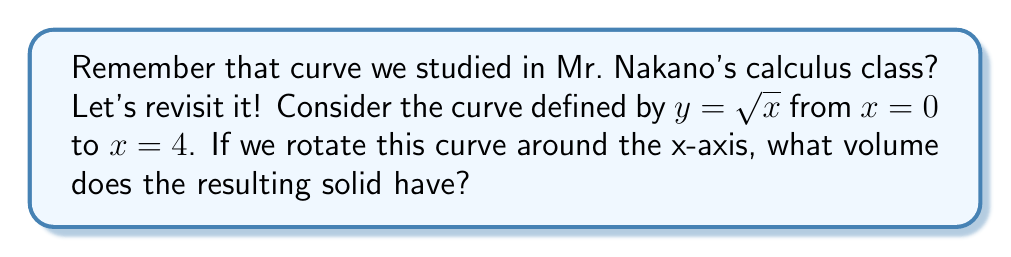What is the answer to this math problem? Let's approach this step-by-step:

1) To find the volume of a solid formed by rotating a curve around the x-axis, we use the disk method. The formula is:

   $$V = \pi \int_a^b [f(x)]^2 dx$$

   where $f(x)$ is our function and $[a,b]$ is our interval.

2) In this case, $f(x) = \sqrt{x}$, $a = 0$, and $b = 4$.

3) Let's substitute these into our formula:

   $$V = \pi \int_0^4 (\sqrt{x})^2 dx$$

4) Simplify the integrand:

   $$V = \pi \int_0^4 x dx$$

5) Now we integrate:

   $$V = \pi [\frac{1}{2}x^2]_0^4$$

6) Evaluate the integral:

   $$V = \pi (\frac{1}{2}(4^2) - \frac{1}{2}(0^2))$$
   $$V = \pi (8 - 0)$$
   $$V = 8\pi$$

Therefore, the volume of the solid is $8\pi$ cubic units.
Answer: $8\pi$ cubic units 